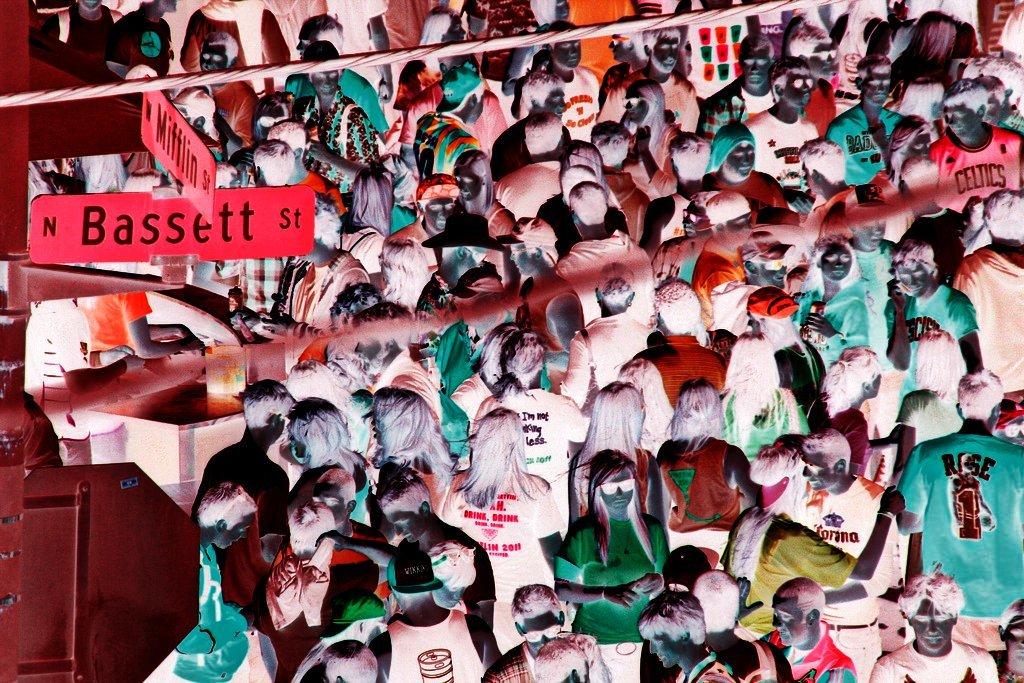What direction does the steet go?
Ensure brevity in your answer.  North. 